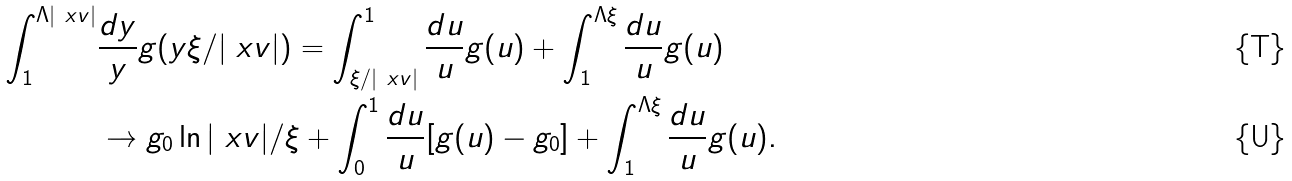Convert formula to latex. <formula><loc_0><loc_0><loc_500><loc_500>\int _ { 1 } ^ { \Lambda | \ x v | } & \frac { d y } { y } g ( y \xi / | \ x v | ) = \int _ { \xi / | \ x v | } ^ { 1 } \frac { d u } { u } g ( u ) + \int _ { 1 } ^ { \Lambda \xi } \frac { d u } { u } g ( u ) \\ & \rightarrow g _ { 0 } \ln | \ x v | / \xi + \int _ { 0 } ^ { 1 } \frac { d u } { u } [ g ( u ) - g _ { 0 } ] + \int _ { 1 } ^ { \Lambda \xi } \frac { d u } { u } g ( u ) .</formula> 